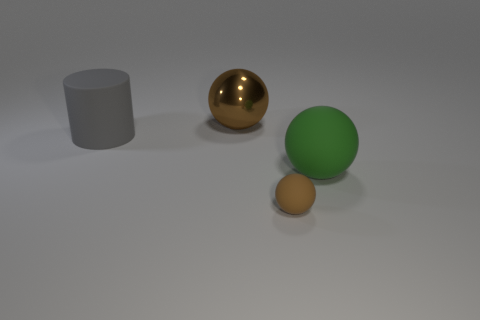Subtract all rubber spheres. How many spheres are left? 1 Add 4 big yellow shiny things. How many objects exist? 8 Subtract all spheres. How many objects are left? 1 Add 4 tiny matte things. How many tiny matte things exist? 5 Subtract 0 purple balls. How many objects are left? 4 Subtract all large gray metal things. Subtract all large matte cylinders. How many objects are left? 3 Add 4 cylinders. How many cylinders are left? 5 